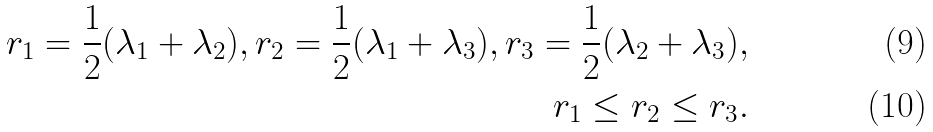Convert formula to latex. <formula><loc_0><loc_0><loc_500><loc_500>r _ { 1 } = \frac { 1 } { 2 } ( \lambda _ { 1 } + \lambda _ { 2 } ) , r _ { 2 } = \frac { 1 } { 2 } ( \lambda _ { 1 } + \lambda _ { 3 } ) , r _ { 3 } = \frac { 1 } { 2 } ( \lambda _ { 2 } + \lambda _ { 3 } ) , \\ r _ { 1 } \leq r _ { 2 } \leq r _ { 3 } .</formula> 